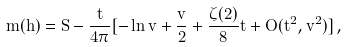<formula> <loc_0><loc_0><loc_500><loc_500>m ( h ) = S - \frac { t } { 4 \pi } { [ - \ln v + \frac { v } { 2 } + \frac { \zeta ( 2 ) } { 8 } t + O ( t ^ { 2 } , v ^ { 2 } ) ] } \, ,</formula> 